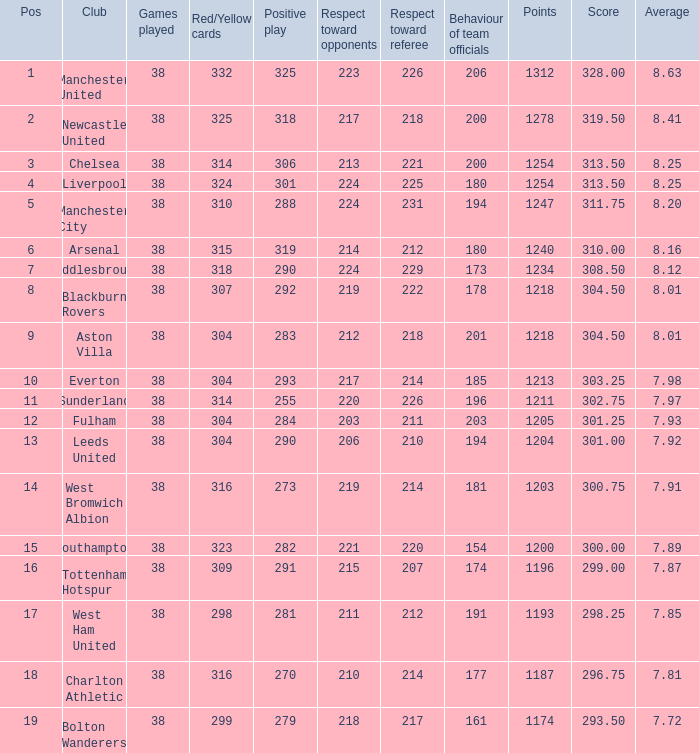Name the most pos for west bromwich albion club 14.0. 